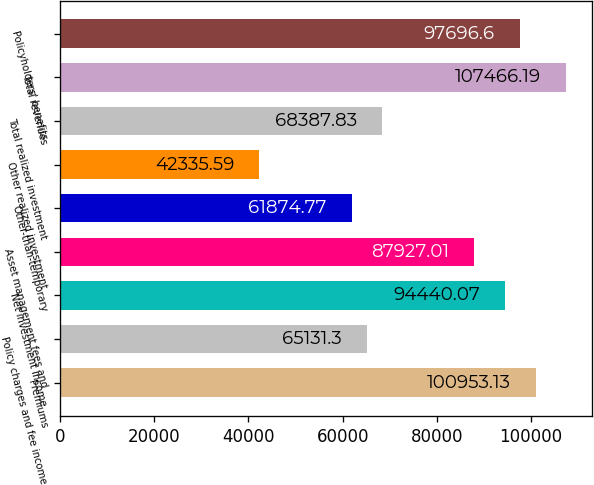Convert chart. <chart><loc_0><loc_0><loc_500><loc_500><bar_chart><fcel>Premiums<fcel>Policy charges and fee income<fcel>Net investment income<fcel>Asset management fees and<fcel>Other-than-temporary<fcel>Other realized investment<fcel>Total realized investment<fcel>Total revenues<fcel>Policyholders' benefits<nl><fcel>100953<fcel>65131.3<fcel>94440.1<fcel>87927<fcel>61874.8<fcel>42335.6<fcel>68387.8<fcel>107466<fcel>97696.6<nl></chart> 